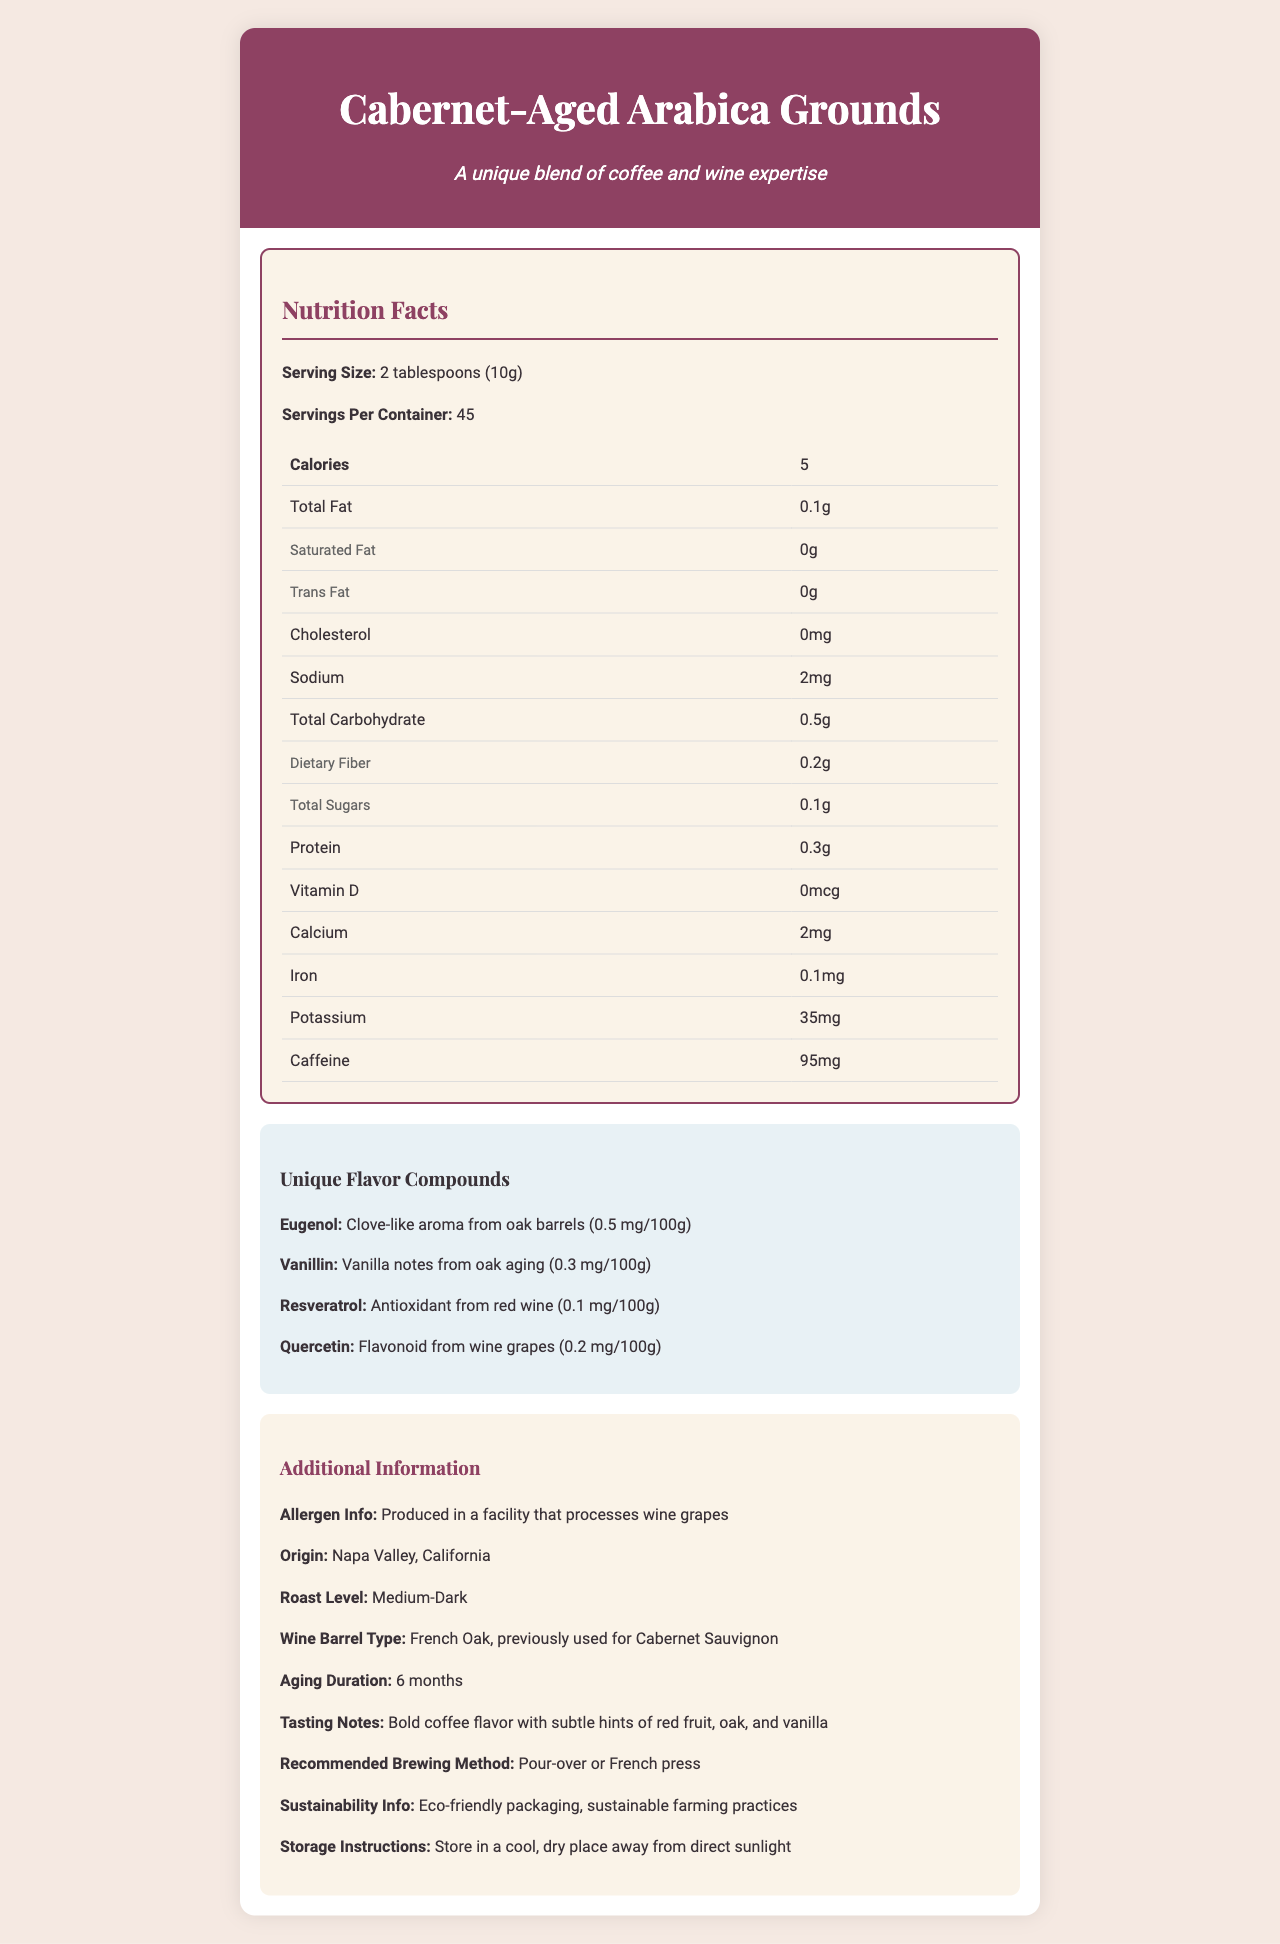what is the serving size of the Cabernet-Aged Arabica Grounds? The serving size is listed at the beginning of the nutrition facts section: "Serving Size: 2 tablespoons (10g)".
Answer: 2 tablespoons (10g) how many calories are there in one serving? The calories per serving are indicated in the nutrition facts table under the "Calories" row.
Answer: 5 what is the concentration of Vanillin in the unique flavor compounds? The concentration of Vanillin is specified in the unique flavor compounds section: "Vanillin: Vanilla notes from oak aging (0.3 mg/100g)".
Answer: 0.3 mg/100g which unique flavor compound provides a clove-like aroma? A. Vanillin B. Eugenol C. Resveratrol D. Quercetin Eugenol provides a clove-like aroma from oak barrels as listed in the unique flavor compounds section.
Answer: B how many servings are in one container? The number of servings per container is clearly stated as "Servings Per Container: 45".
Answer: 45 what type of wine barrels were used to age the coffee beans? The type of wine barrels is specified under additional information as "Wine Barrel Type: French Oak, previously used for Cabernet Sauvignon".
Answer: French Oak, previously used for Cabernet Sauvignon is the product produced in a facility that processes wine grapes? The allergen information mentions: "Produced in a facility that processes wine grapes".
Answer: Yes what is the recommended brewing method for the coffee grounds? A. Espresso B. French Press C. Cold Brew D. Percolator The recommended brewing method is "Pour-over or French press" as mentioned in the additional information.
Answer: B how long were the coffee beans aged in the wine barrels? The aging duration is provided in the additional information: "Aging Duration: 6 months".
Answer: 6 months what is the total carbohydrate content per serving? The total carbohydrate content per serving is listed under "Total Carbohydrate" in the nutrition facts table: "Total Carbohydrate: 0.5g".
Answer: 0.5g does the product contain any dietary fiber? The product contains dietary fiber, as indicated by "Dietary Fiber: 0.2g" in the nutrition facts table.
Answer: Yes what is the origin of the Cabernet-Aged Arabica Grounds? The origin of the product is mentioned in the additional information as "Origin: Napa Valley, California".
Answer: Napa Valley, California summarize the main idea of the document. The document provides comprehensive information about the Cabernet-Aged Arabica Grounds, including its serving size, nutritional values, flavor compounds from the wine barrel aging process, and additional details such as origin, allergen info, and sustainability practices.
Answer: The document details the nutrition facts, unique flavor compounds, and additional information of Cabernet-Aged Arabica Grounds, a specialty coffee aged in French oak wine barrels previously used for Cabernet Sauvignon, highlighting its nutritional content, distinctive flavors from wine and oak aging, and its recommended brewing method. what type of roast level are the coffee grounds? The roast level is stated in the additional information section as "Roast Level: Medium-Dark".
Answer: Medium-Dark how much caffeine is there per serving of the coffee grounds? The caffeine content per serving is specified in the nutrition facts table: "Caffeine: 95mg".
Answer: 95mg what is the exact amount of potassium in one serving of the coffee grounds? The amount of potassium is listed under "Potassium" in the nutrition facts table: "Potassium: 35mg".
Answer: 35mg how much saturated fat does one serving of the coffee grounds contain? The saturated fat content per serving is specified under "Saturated Fat" in the nutrition facts table: "Saturated Fat: 0g".
Answer: 0g where was the French oak barrel sourced from? The document does not provide specific information on the source of the French oak barrel.
Answer: Cannot be determined 